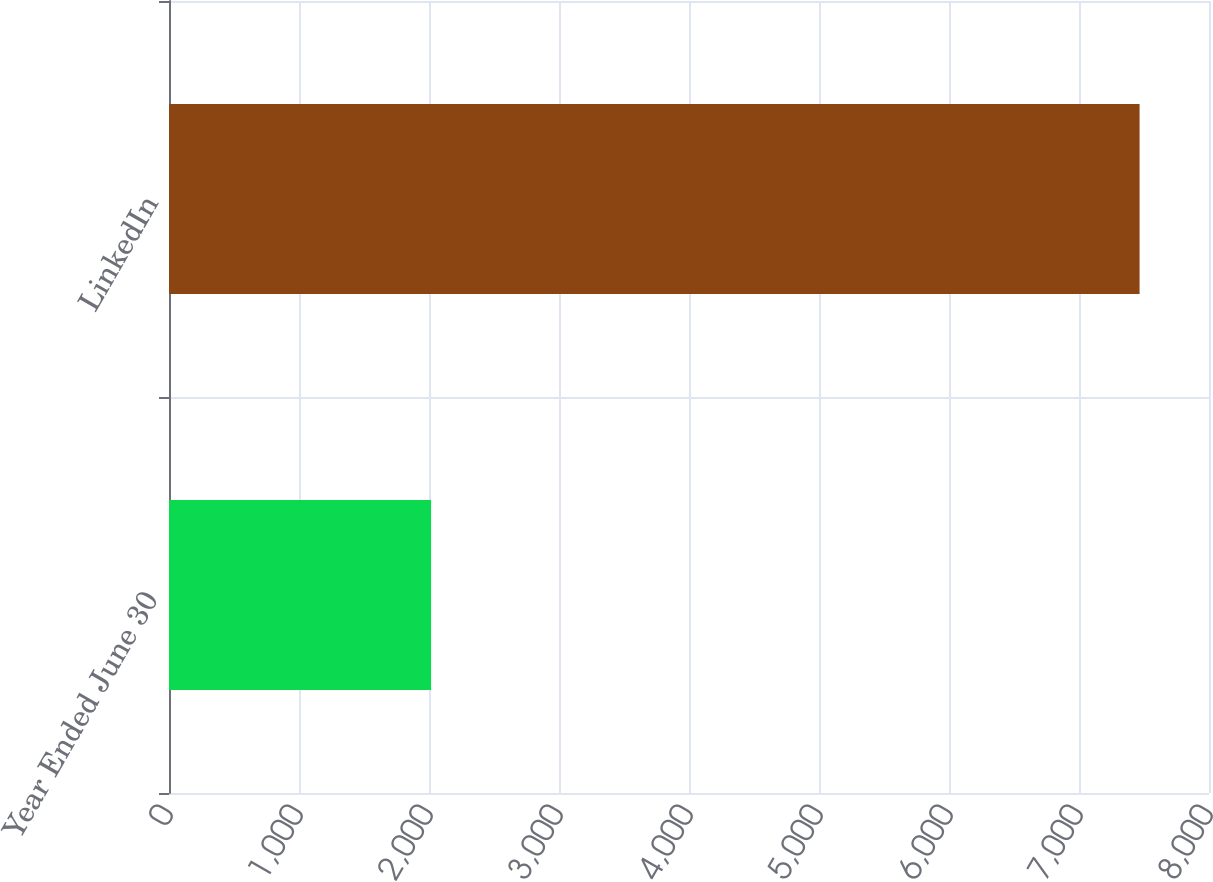<chart> <loc_0><loc_0><loc_500><loc_500><bar_chart><fcel>Year Ended June 30<fcel>LinkedIn<nl><fcel>2016<fcel>7466<nl></chart> 